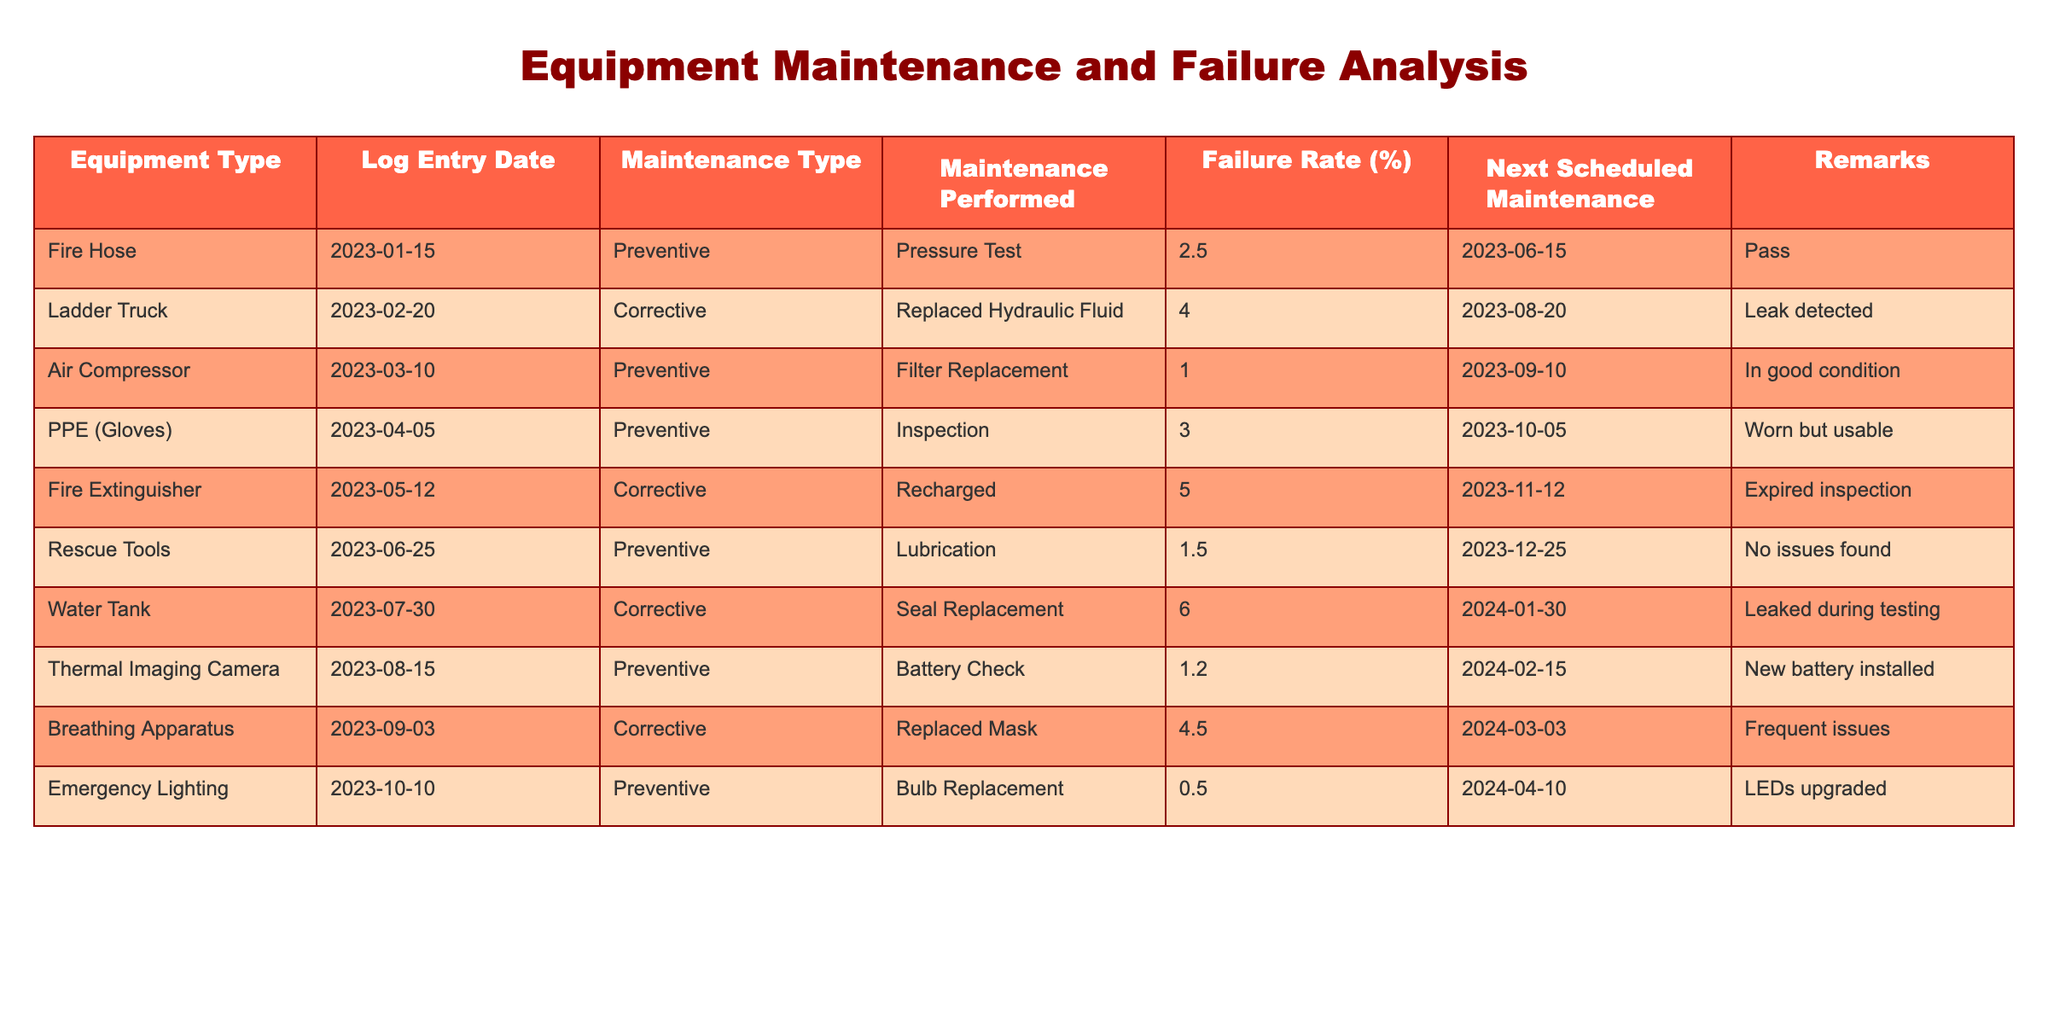What is the failure rate of the Fire Hose? The failure rate of the Fire Hose can be found directly in the table under the "Failure Rate (%)" column. It shows 2.5%.
Answer: 2.5% Which piece of equipment has the highest failure rate? By reviewing the "Failure Rate (%)" column, the Water Tank has the highest failure rate at 6.0%.
Answer: Water Tank How often is the next scheduled maintenance after the last maintenance for the Breathing Apparatus? The last maintenance for the Breathing Apparatus was on 2023-09-03, and the next scheduled maintenance is on 2024-03-03. This means it is scheduled 6 months later.
Answer: 6 months What is the average failure rate of the equipment that underwent corrective maintenance? We identify the equipment that underwent corrective maintenance: Ladder Truck (4.0%), Fire Extinguisher (5.0%), Water Tank (6.0%), and Breathing Apparatus (4.5%). The total failure rate is (4.0 + 5.0 + 6.0 + 4.5) = 19.5%, and there are 4 pieces of equipment, thus the average is 19.5/4 = 4.875%.
Answer: 4.875% Did the Emergency Lighting undergo corrective maintenance? Looking at the "Maintenance Type" column for Emergency Lighting, it shows "Preventive". Therefore, it did not undergo corrective maintenance.
Answer: No Which preventive maintenance task had the lowest failure rate? The table lists the failure rates for preventive maintenance tasks: Air Compressor (1.0%), Rescue Tools (1.5%), Thermal Imaging Camera (1.2%), and Emergency Lighting (0.5%). The lowest failure rate among these is for the Emergency Lighting at 0.5%.
Answer: Emergency Lighting How many pieces of equipment were inspected as part of preventive maintenance? From the table, the equipment types that fall under preventive maintenance are: Fire Hose, Air Compressor, PPE Gloves, Rescue Tools, Thermal Imaging Camera, and Emergency Lighting – totaling 6 pieces of equipment.
Answer: 6 If the Fire Extinguisher had not expired, what would its next scheduled maintenance be? The next scheduled maintenance for the Fire Extinguisher is set for 2023-11-12, regardless of its expired inspection status. Therefore, it would still be the same date.
Answer: 2023-11-12 Is the PPE (Gloves) still considered usable despite being worn? The remarks column states "Worn but usable", indicating that it is still usable. Therefore, the answer is yes.
Answer: Yes 